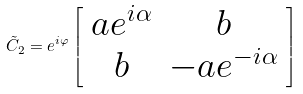Convert formula to latex. <formula><loc_0><loc_0><loc_500><loc_500>\tilde { C } _ { 2 } = e ^ { i \varphi } \left [ \begin{array} { c c } a e ^ { i \alpha } & b \\ b & - a e ^ { - i \alpha } \end{array} \right ]</formula> 